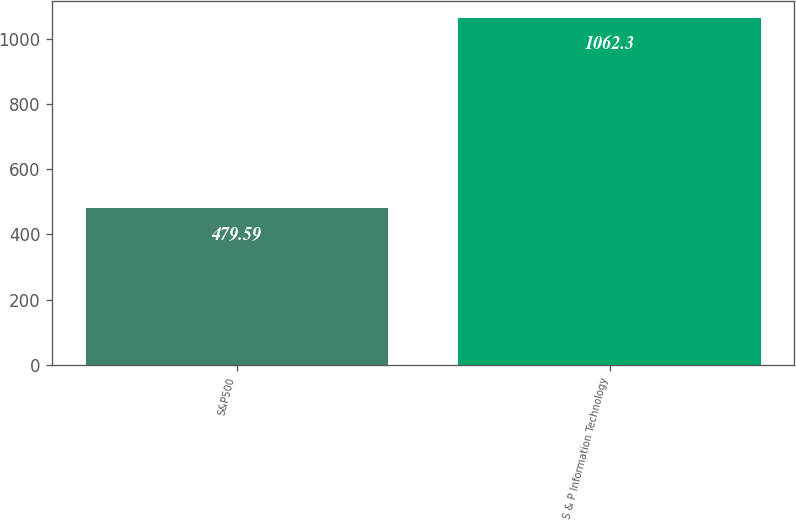Convert chart to OTSL. <chart><loc_0><loc_0><loc_500><loc_500><bar_chart><fcel>S&P500<fcel>S & P Information Technology<nl><fcel>479.59<fcel>1062.3<nl></chart> 